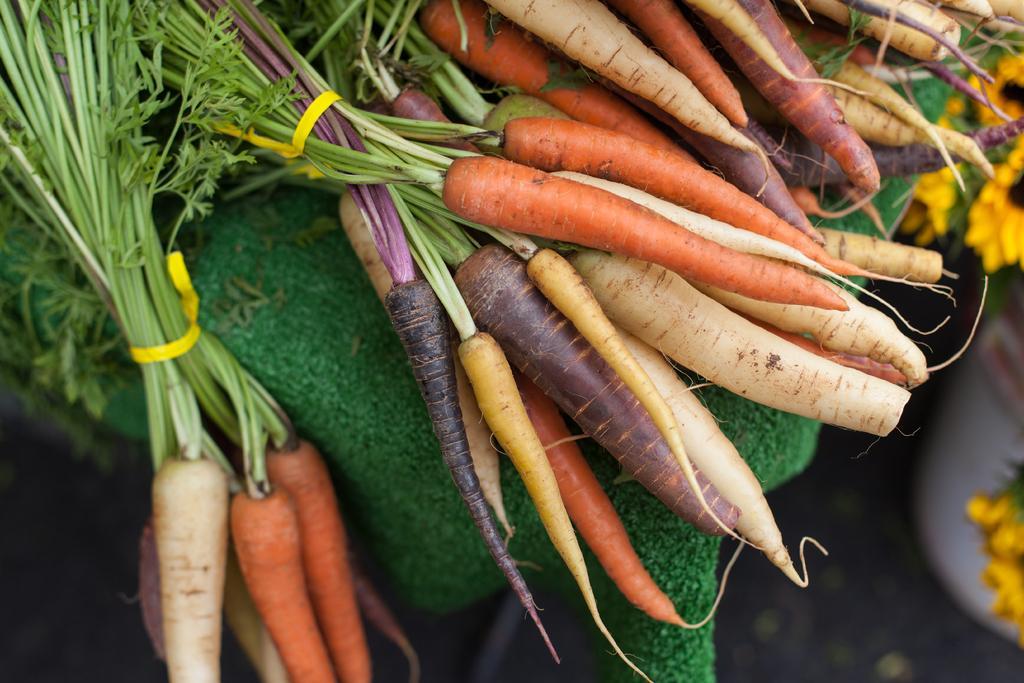In one or two sentences, can you explain what this image depicts? In the image there are carrots and radishes on a table with flowers below it. 